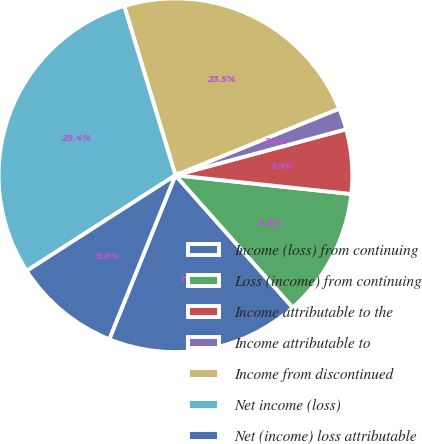<chart> <loc_0><loc_0><loc_500><loc_500><pie_chart><fcel>Income (loss) from continuing<fcel>Loss (income) from continuing<fcel>Income attributable to the<fcel>Income attributable to<fcel>Income from discontinued<fcel>Net income (loss)<fcel>Net (income) loss attributable<nl><fcel>17.65%<fcel>11.76%<fcel>5.88%<fcel>1.96%<fcel>23.53%<fcel>29.41%<fcel>9.8%<nl></chart> 